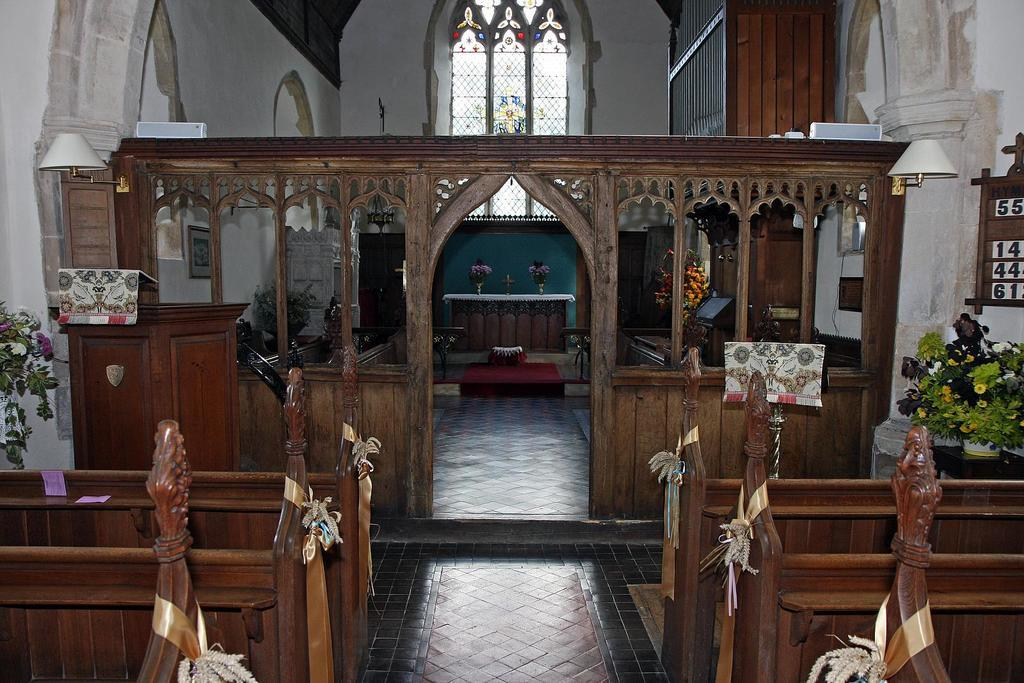What type of building is shown in the image? The image depicts the inside view of a church. What type of seating is available in the church? There are benches in the image. Are there any natural elements present in the church? Yes, there are plants in the image. What type of lighting is used in the church? There are lights in the image. What type of decorative feature can be seen in the background of the image? There is stained glass in the background of the image. How many tomatoes are on the ship in the image? There is no ship or tomatoes present in the image. The image shows the inside view of a church. 